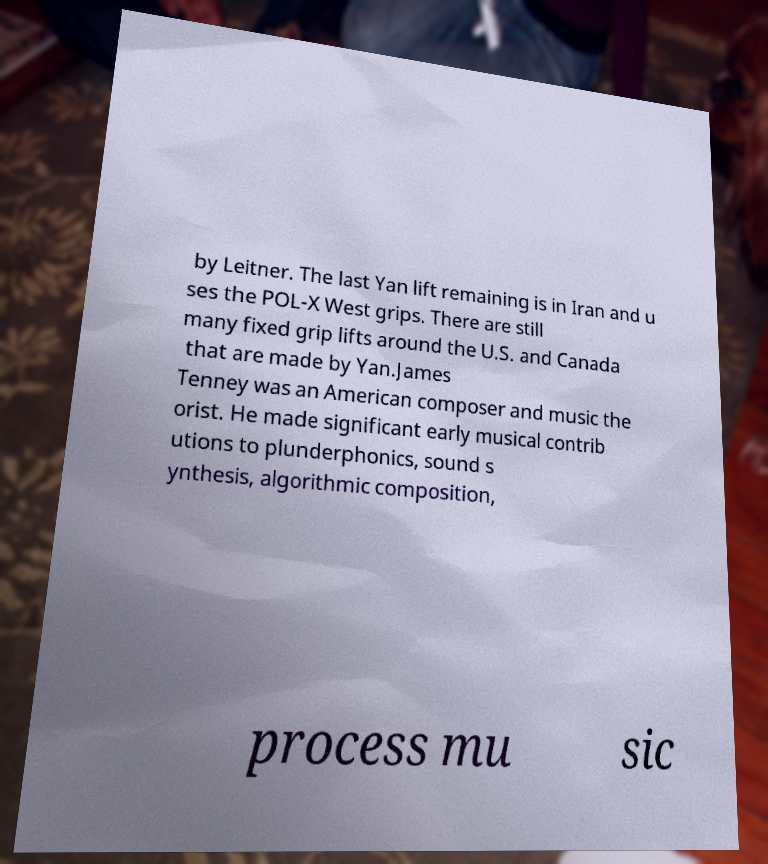Can you read and provide the text displayed in the image?This photo seems to have some interesting text. Can you extract and type it out for me? by Leitner. The last Yan lift remaining is in Iran and u ses the POL-X West grips. There are still many fixed grip lifts around the U.S. and Canada that are made by Yan.James Tenney was an American composer and music the orist. He made significant early musical contrib utions to plunderphonics, sound s ynthesis, algorithmic composition, process mu sic 